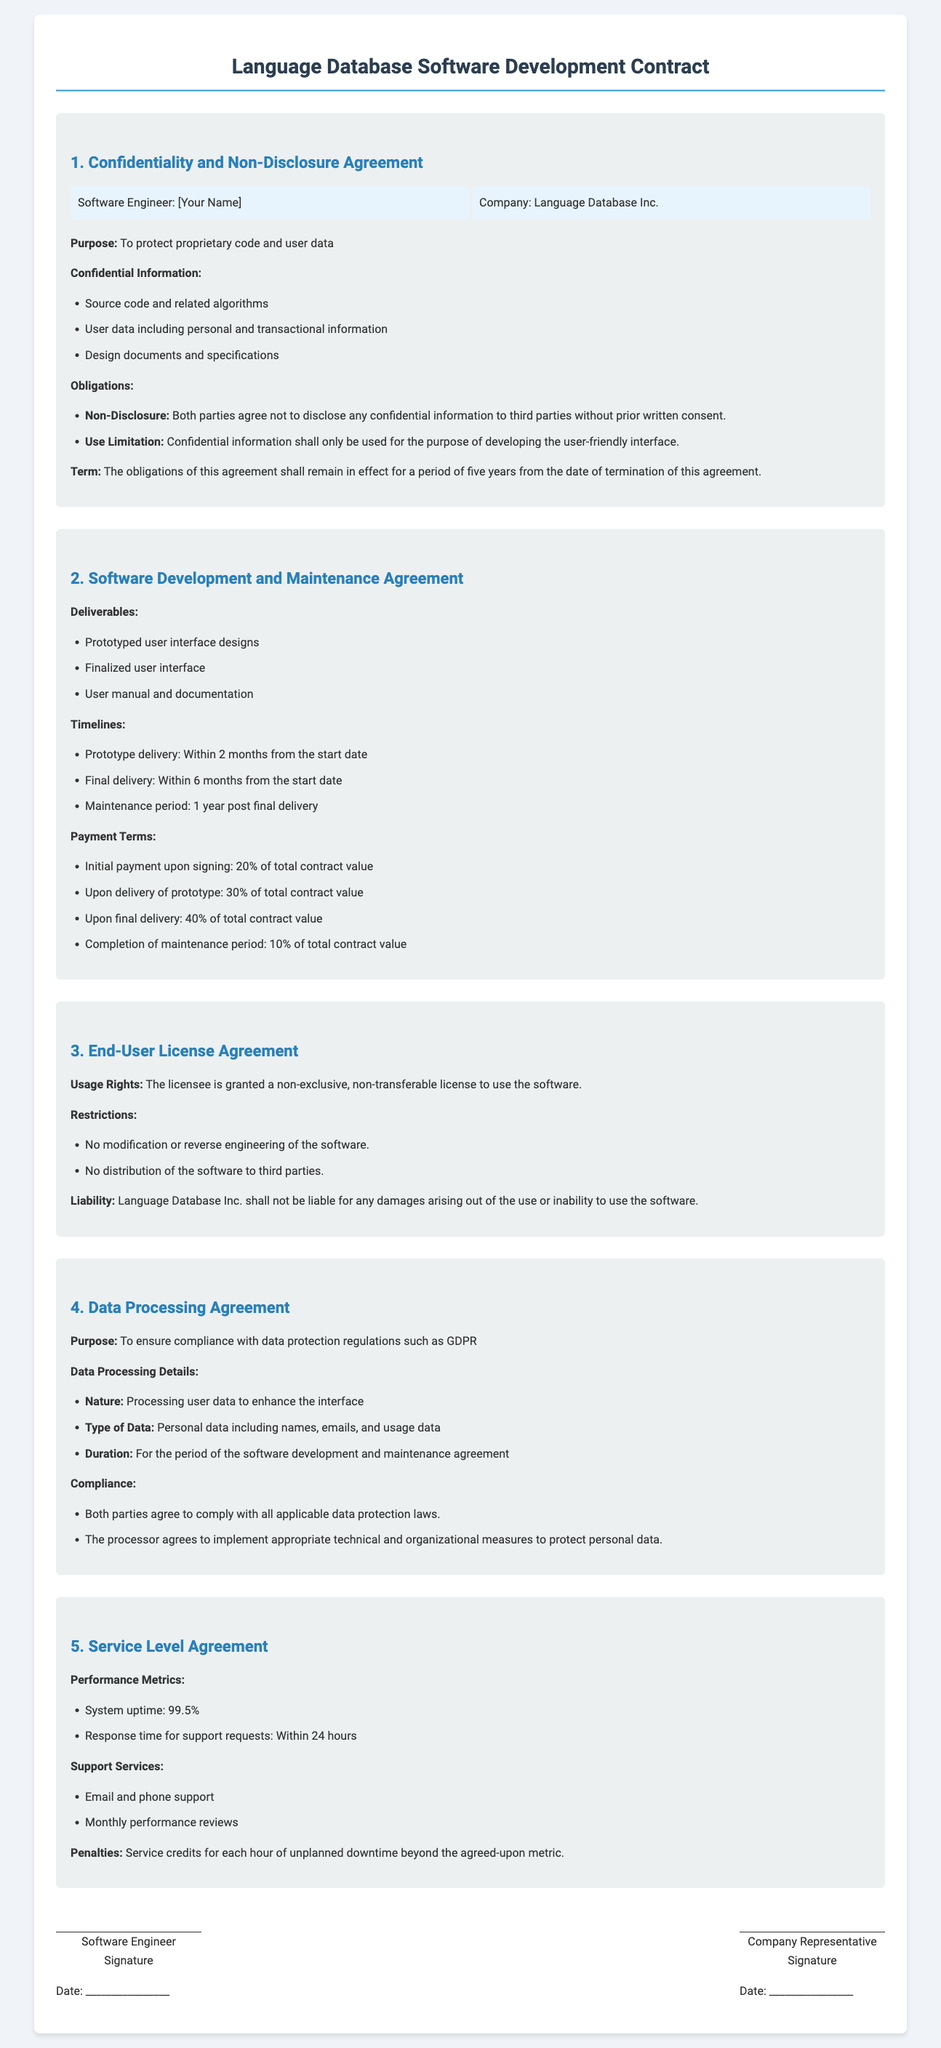What is the name of the company? The company involved in the contract is Language Database Inc.
Answer: Language Database Inc What is the initial payment percentage upon signing? The document specifies the initial payment as 20% of the total contract value.
Answer: 20% What is the duration of the maintenance period? The maintenance period mentioned is 1 year post final delivery.
Answer: 1 year How long is the confidentiality obligation effective? The obligations of the confidentiality agreement remain in effect for five years.
Answer: five years What is the system uptime specified in the Service Level Agreement? The document states the required system uptime at 99.5%.
Answer: 99.5% What type of support services are provided according to the SLA? The document lists email and phone support as part of the support services.
Answer: Email and phone support What is one restriction placed on the licensee in the End-User License Agreement? One restriction is that the licensee cannot modify or reverse engineer the software.
Answer: No modification or reverse engineering What types of data are processed under the Data Processing Agreement? The document specifies personal data including names, emails, and usage data.
Answer: Personal data including names, emails, and usage data What must both parties comply with according to the Data Processing Agreement? The document states that both parties must comply with all applicable data protection laws.
Answer: All applicable data protection laws 